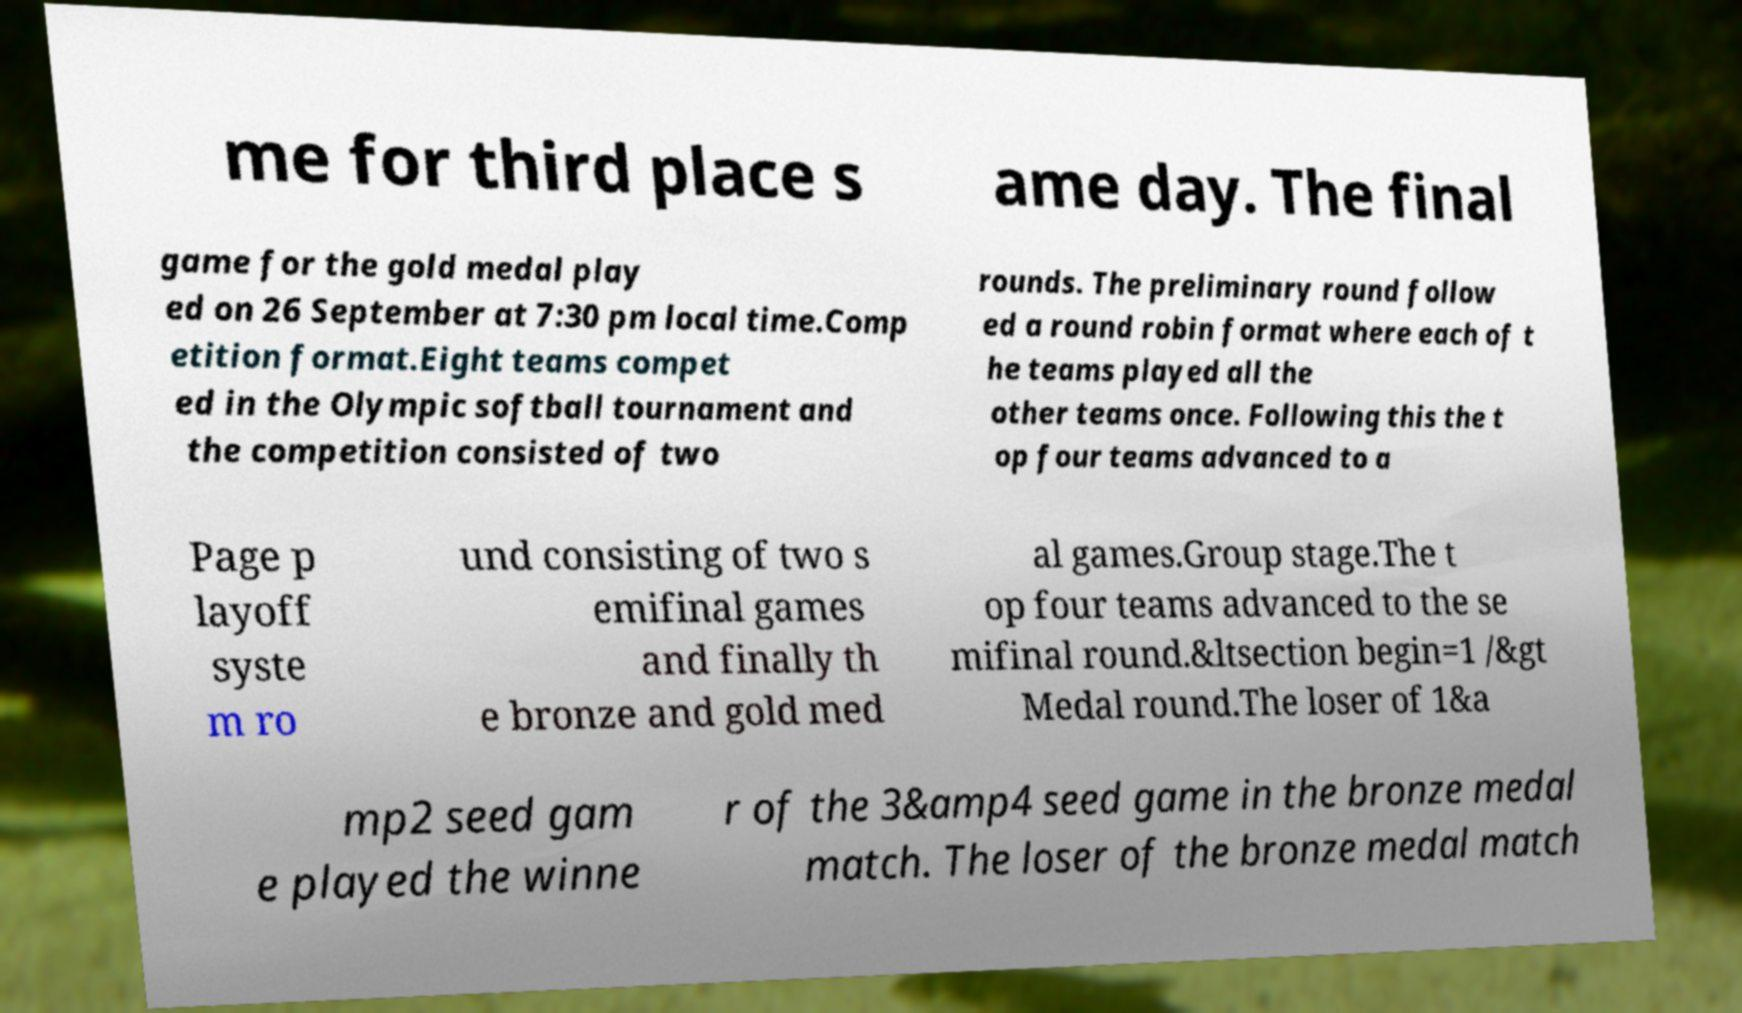What messages or text are displayed in this image? I need them in a readable, typed format. me for third place s ame day. The final game for the gold medal play ed on 26 September at 7:30 pm local time.Comp etition format.Eight teams compet ed in the Olympic softball tournament and the competition consisted of two rounds. The preliminary round follow ed a round robin format where each of t he teams played all the other teams once. Following this the t op four teams advanced to a Page p layoff syste m ro und consisting of two s emifinal games and finally th e bronze and gold med al games.Group stage.The t op four teams advanced to the se mifinal round.&ltsection begin=1 /&gt Medal round.The loser of 1&a mp2 seed gam e played the winne r of the 3&amp4 seed game in the bronze medal match. The loser of the bronze medal match 